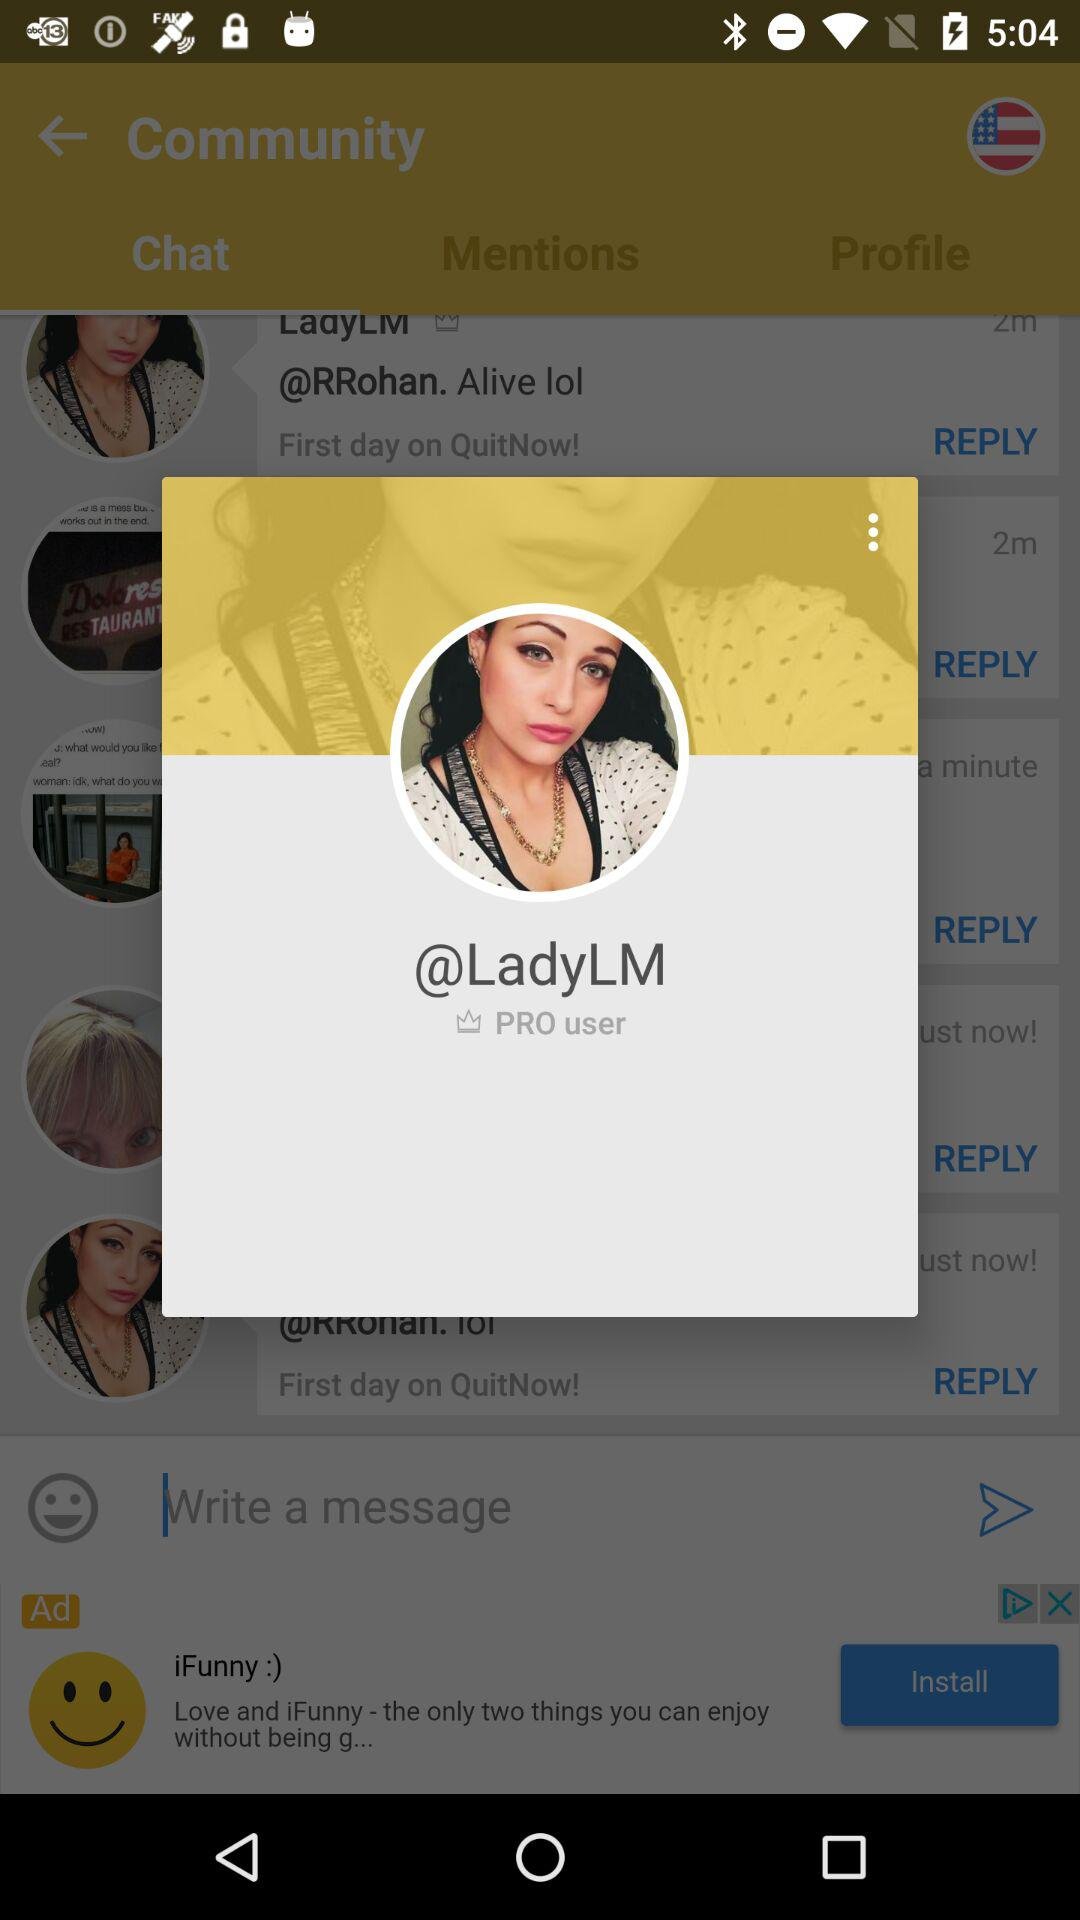What is the username? The username is "LadyLM". 